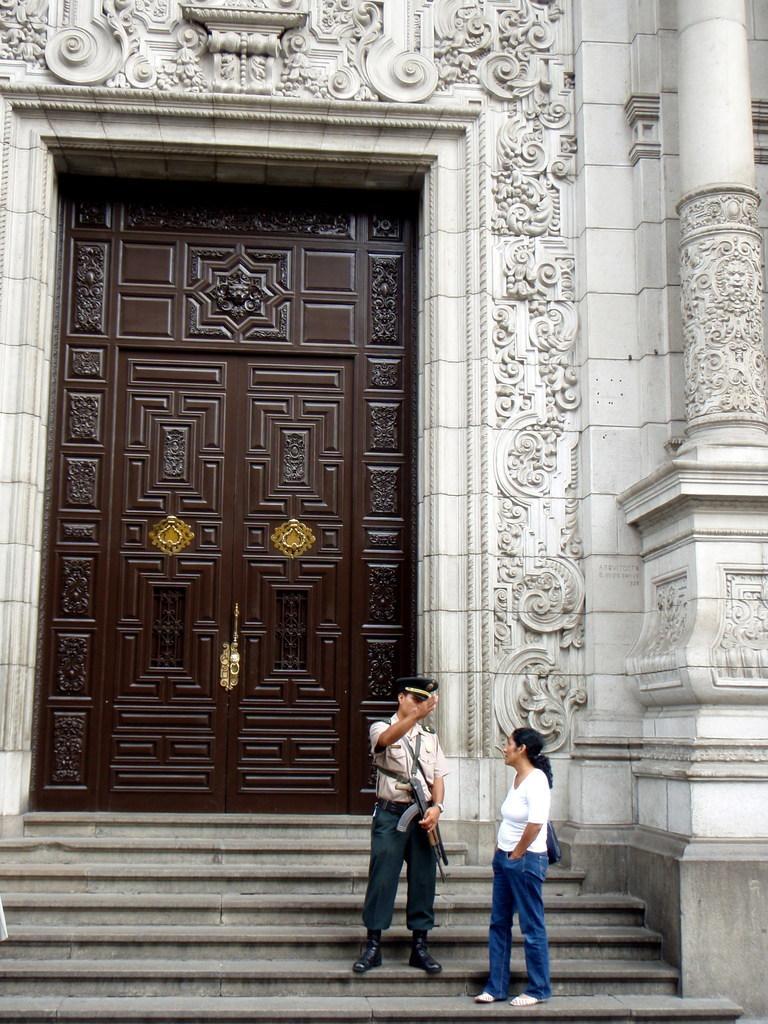In one or two sentences, can you explain what this image depicts? In this image we can see persons standing on the staircase and of them is holding gun in the hand. In the background we can see door, sculptures on the wall and pillars. 